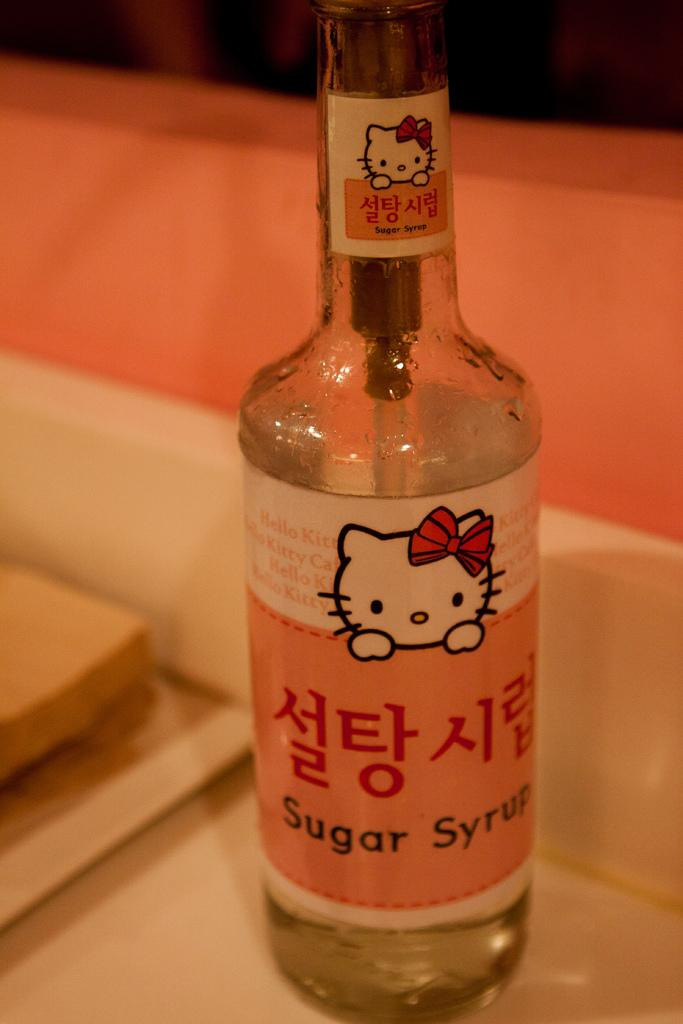<image>
Give a short and clear explanation of the subsequent image. A bottle of Sugar Syrup with a small white kitty on the label. 